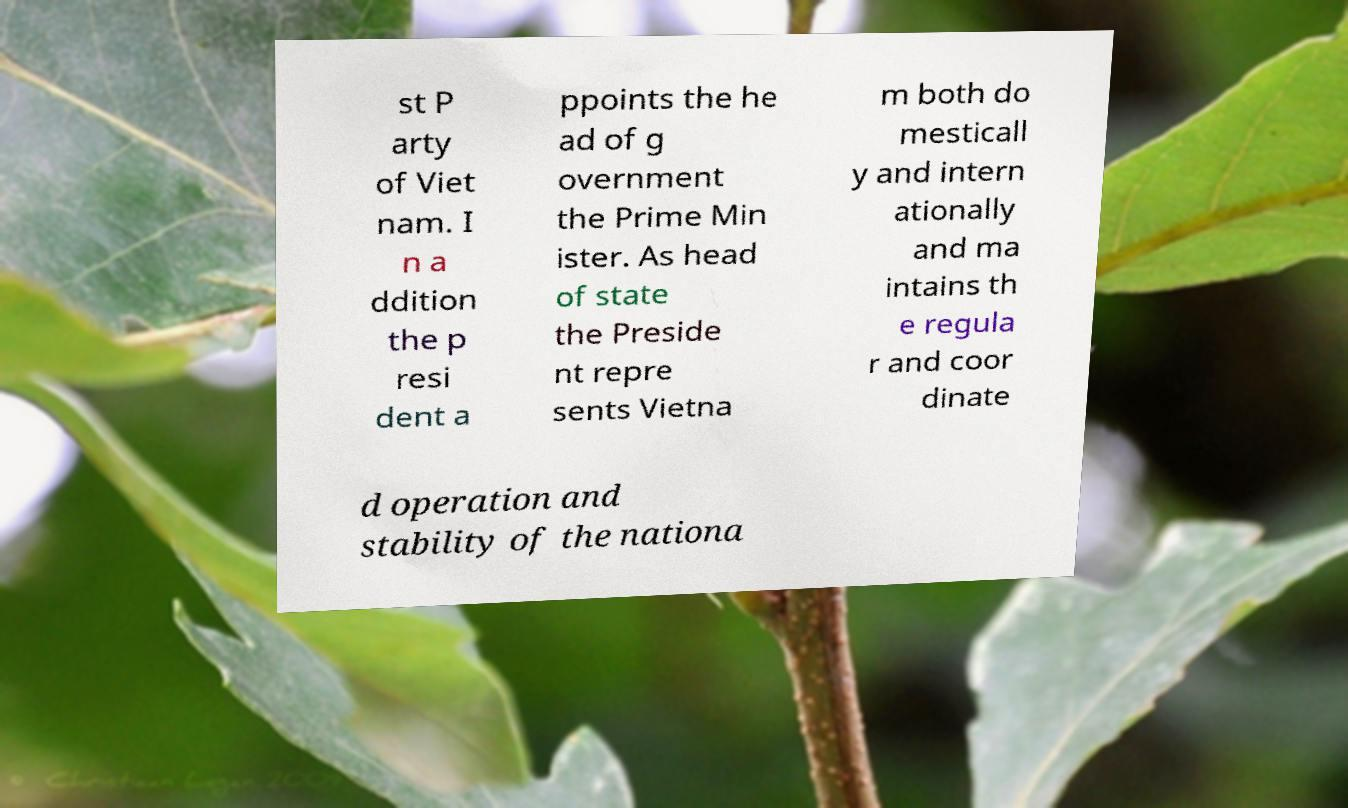For documentation purposes, I need the text within this image transcribed. Could you provide that? st P arty of Viet nam. I n a ddition the p resi dent a ppoints the he ad of g overnment the Prime Min ister. As head of state the Preside nt repre sents Vietna m both do mesticall y and intern ationally and ma intains th e regula r and coor dinate d operation and stability of the nationa 